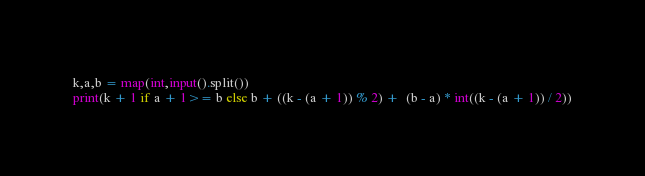Convert code to text. <code><loc_0><loc_0><loc_500><loc_500><_Python_>k,a,b = map(int,input().split())
print(k + 1 if a + 1>= b else b + ((k - (a + 1)) % 2) +  (b - a) * int((k - (a + 1)) / 2))</code> 